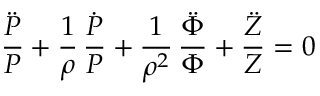<formula> <loc_0><loc_0><loc_500><loc_500>{ \frac { \ddot { P } } { P } } + { \frac { 1 } { \rho } } \, { \frac { \dot { P } } { P } } + { \frac { 1 } { \rho ^ { 2 } } } \, { \frac { \ddot { \Phi } } { \Phi } } + { \frac { \ddot { Z } } { Z } } = 0</formula> 